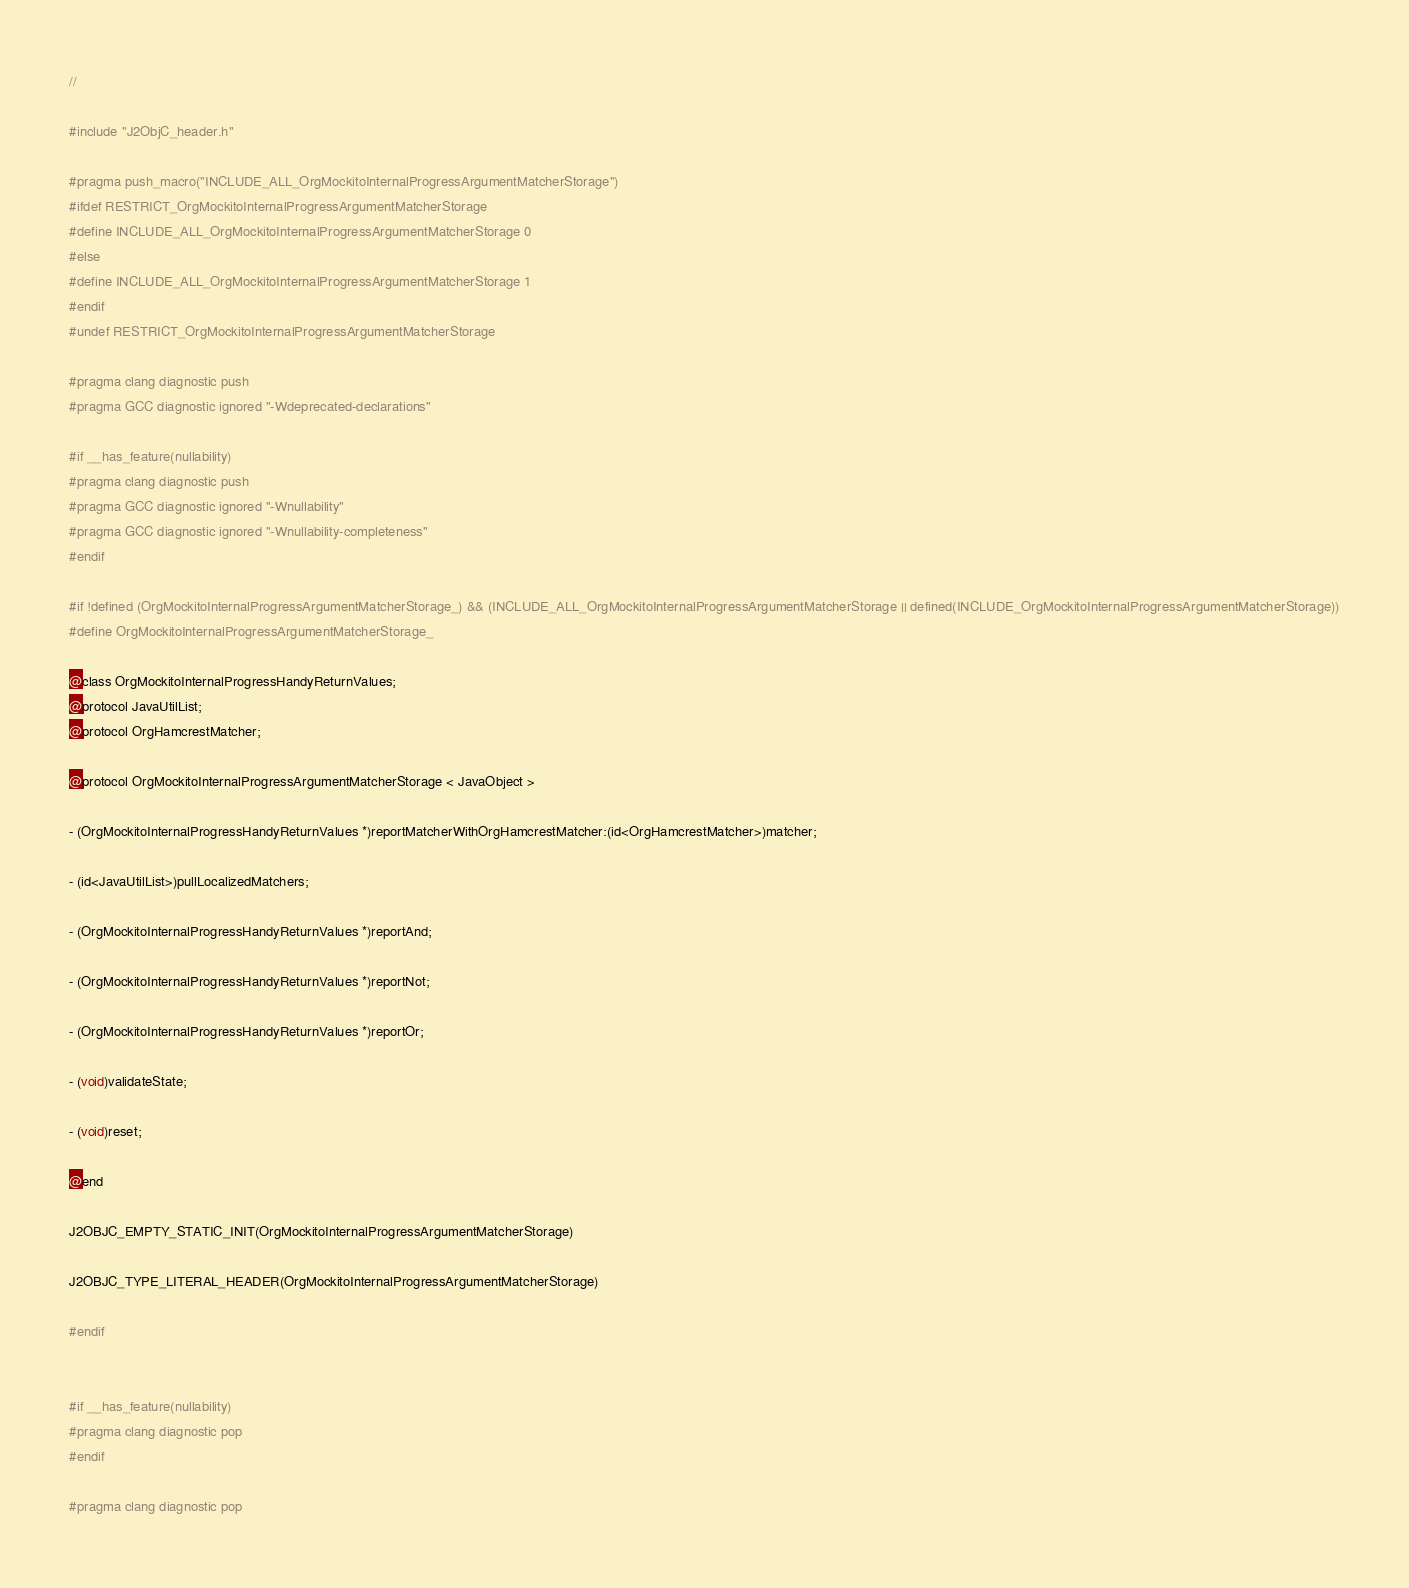Convert code to text. <code><loc_0><loc_0><loc_500><loc_500><_C_>//

#include "J2ObjC_header.h"

#pragma push_macro("INCLUDE_ALL_OrgMockitoInternalProgressArgumentMatcherStorage")
#ifdef RESTRICT_OrgMockitoInternalProgressArgumentMatcherStorage
#define INCLUDE_ALL_OrgMockitoInternalProgressArgumentMatcherStorage 0
#else
#define INCLUDE_ALL_OrgMockitoInternalProgressArgumentMatcherStorage 1
#endif
#undef RESTRICT_OrgMockitoInternalProgressArgumentMatcherStorage

#pragma clang diagnostic push
#pragma GCC diagnostic ignored "-Wdeprecated-declarations"

#if __has_feature(nullability)
#pragma clang diagnostic push
#pragma GCC diagnostic ignored "-Wnullability"
#pragma GCC diagnostic ignored "-Wnullability-completeness"
#endif

#if !defined (OrgMockitoInternalProgressArgumentMatcherStorage_) && (INCLUDE_ALL_OrgMockitoInternalProgressArgumentMatcherStorage || defined(INCLUDE_OrgMockitoInternalProgressArgumentMatcherStorage))
#define OrgMockitoInternalProgressArgumentMatcherStorage_

@class OrgMockitoInternalProgressHandyReturnValues;
@protocol JavaUtilList;
@protocol OrgHamcrestMatcher;

@protocol OrgMockitoInternalProgressArgumentMatcherStorage < JavaObject >

- (OrgMockitoInternalProgressHandyReturnValues *)reportMatcherWithOrgHamcrestMatcher:(id<OrgHamcrestMatcher>)matcher;

- (id<JavaUtilList>)pullLocalizedMatchers;

- (OrgMockitoInternalProgressHandyReturnValues *)reportAnd;

- (OrgMockitoInternalProgressHandyReturnValues *)reportNot;

- (OrgMockitoInternalProgressHandyReturnValues *)reportOr;

- (void)validateState;

- (void)reset;

@end

J2OBJC_EMPTY_STATIC_INIT(OrgMockitoInternalProgressArgumentMatcherStorage)

J2OBJC_TYPE_LITERAL_HEADER(OrgMockitoInternalProgressArgumentMatcherStorage)

#endif


#if __has_feature(nullability)
#pragma clang diagnostic pop
#endif

#pragma clang diagnostic pop</code> 